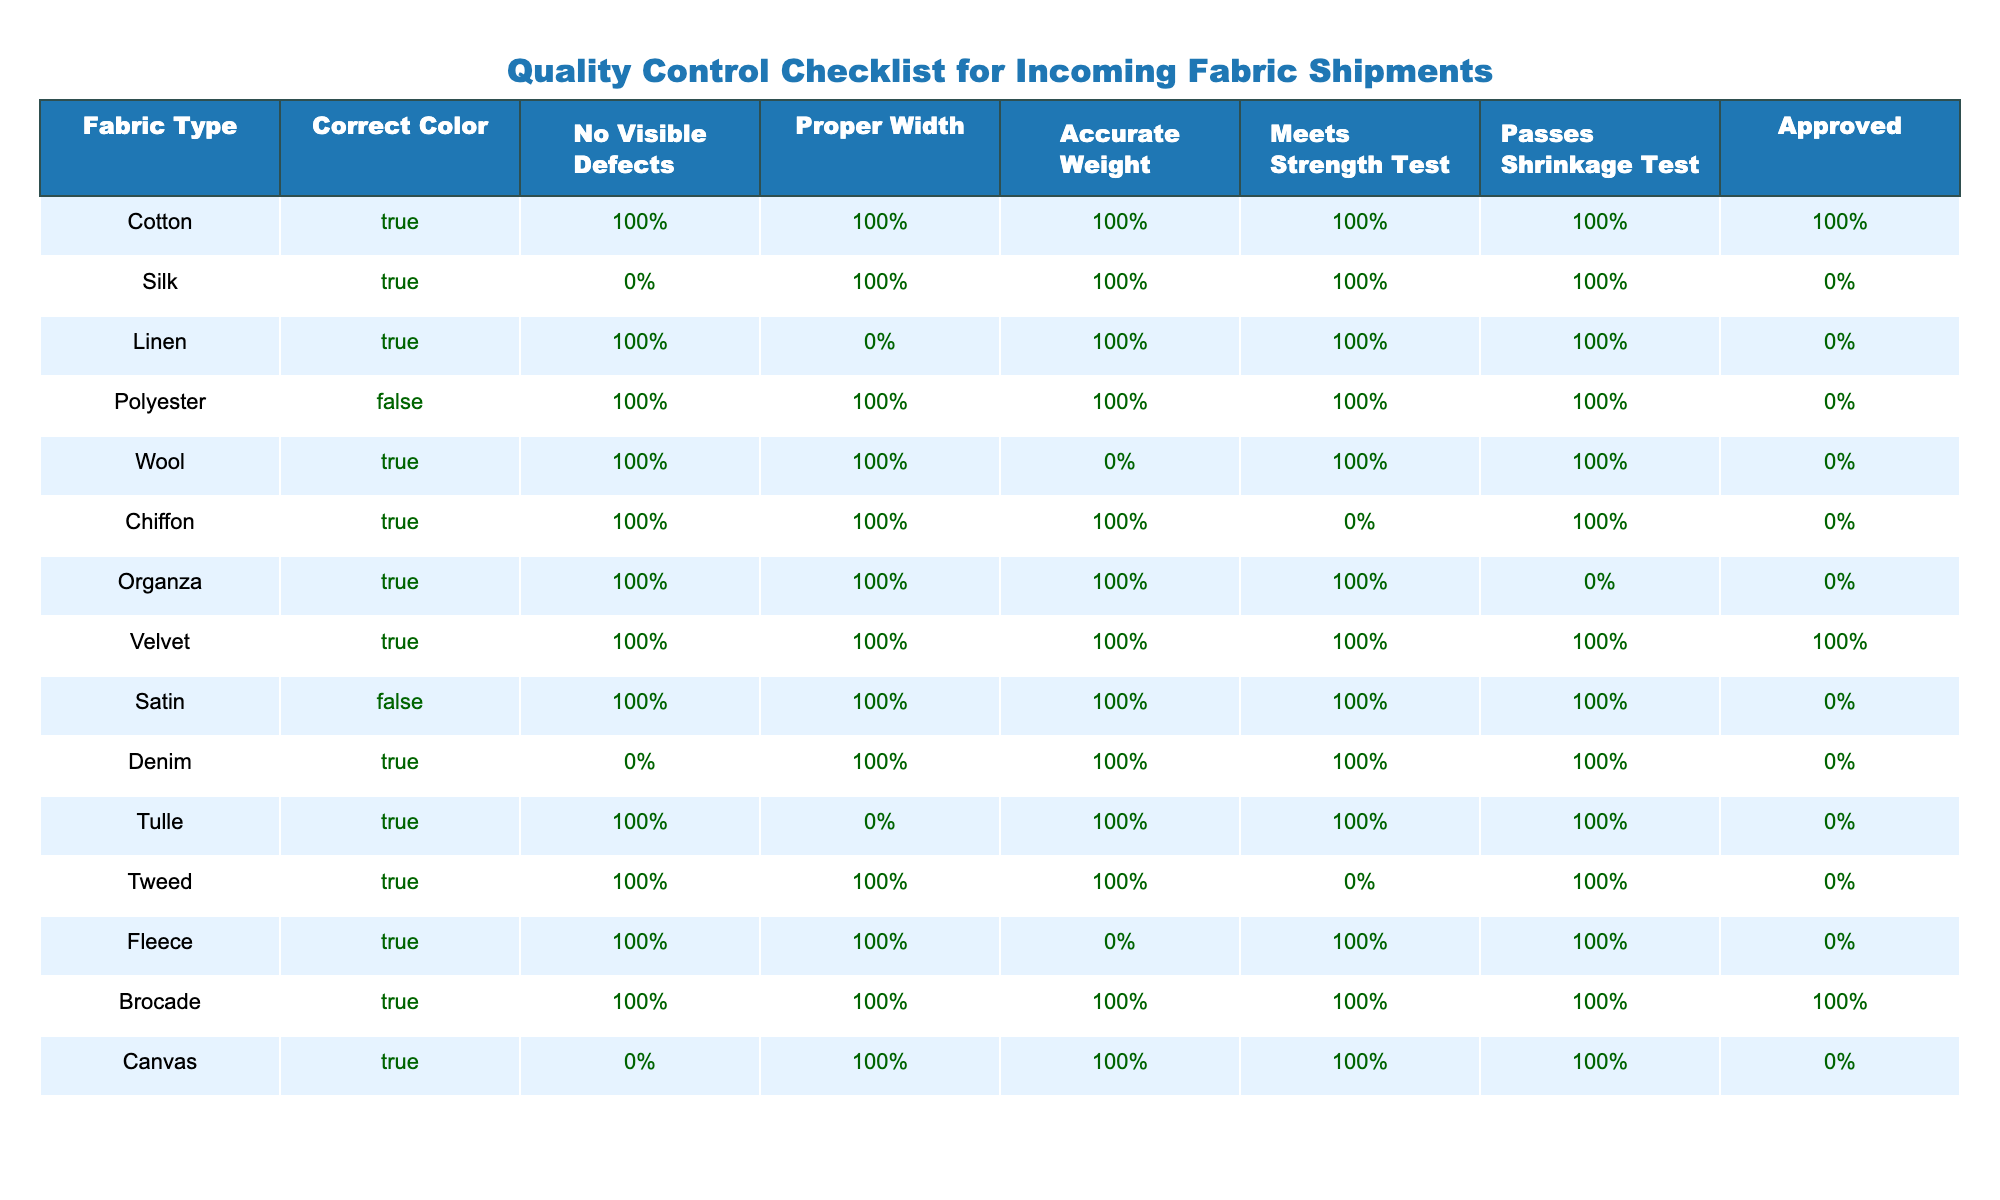What percentage of fabric types approved upon quality control? There are 15 fabric types listed in the table, and 6 of them are marked as approved (TRUE). To find the percentage, we calculate (6/15) * 100, which is 40%.
Answer: 40% How many fabric types did not pass the strength test? By examining the "Meets Strength Test" column, we see that 4 fabric types are marked as FALSE, indicating they did not pass the strength test. These are Silk, Wool, Tulle, and Tweed.
Answer: 4 Is Denim approved according to the quality control checklist? Looking at the row for Denim, the Approved column shows FALSE, indicating that Denim is not approved.
Answer: No Which fabric types have no visible defects but are not approved? The fabric types with "No Visible Defects" marked TRUE but are not approved (FALSE in the Approved column) are Silk, Tulle, and Denim.
Answer: Silk, Tulle, Denim What is the total number of fabric types that passed all tests? By reviewing the table, we see that Velvet and Brocade are the only fabric types with all measurements marked as TRUE. Thus, there are 2 fabric types that passed all tests.
Answer: 2 How many fabric types are made of natural fibers that passed the shrinkage test? The natural fiber fabric types are Cotton, Silk, Linen, Wool, and Tulle. Upon checking the "Passes Shrinkage Test" column, Cotton, Linen, Wool, and Tulle are marked as TRUE, which gives us 4 fabric types that passed the shrinkage test.
Answer: 4 Are there more fabric types with accurate weight or proper width? By counting the entries marked TRUE in "Accurate Weight," we find 10 fabric types. For "Proper Width," we count 10 fabric types as well. Both categories have the same number of fabric types.
Answer: Yes What is the only fabric type that is both approved and has a visible defect? Checking the table, there are no fabric types that are approved (TRUE) and also have visible defects (FALSE). Therefore, there is no such fabric type.
Answer: None 